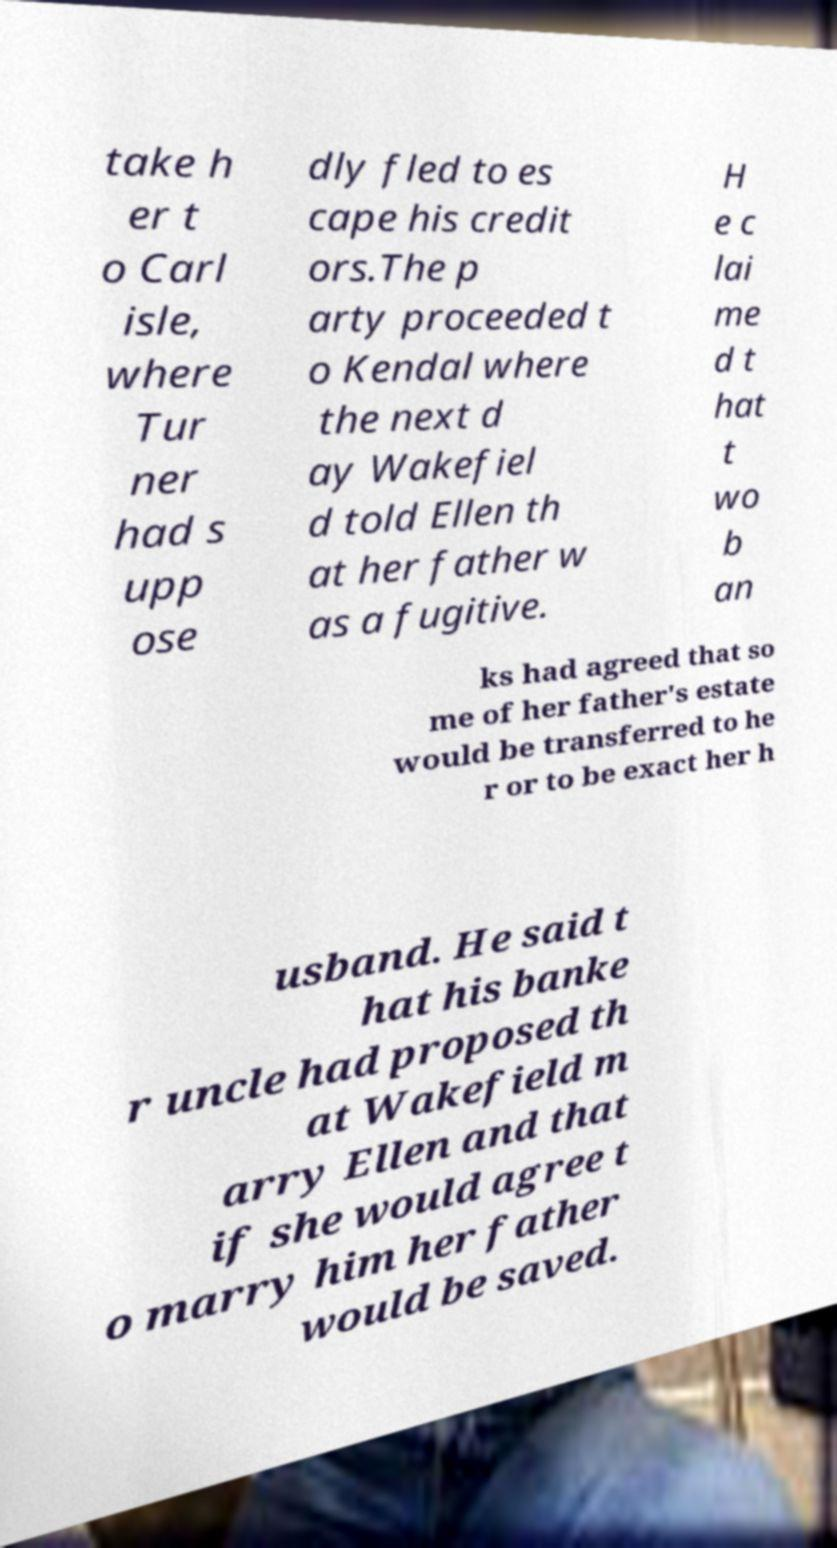Can you accurately transcribe the text from the provided image for me? take h er t o Carl isle, where Tur ner had s upp ose dly fled to es cape his credit ors.The p arty proceeded t o Kendal where the next d ay Wakefiel d told Ellen th at her father w as a fugitive. H e c lai me d t hat t wo b an ks had agreed that so me of her father's estate would be transferred to he r or to be exact her h usband. He said t hat his banke r uncle had proposed th at Wakefield m arry Ellen and that if she would agree t o marry him her father would be saved. 